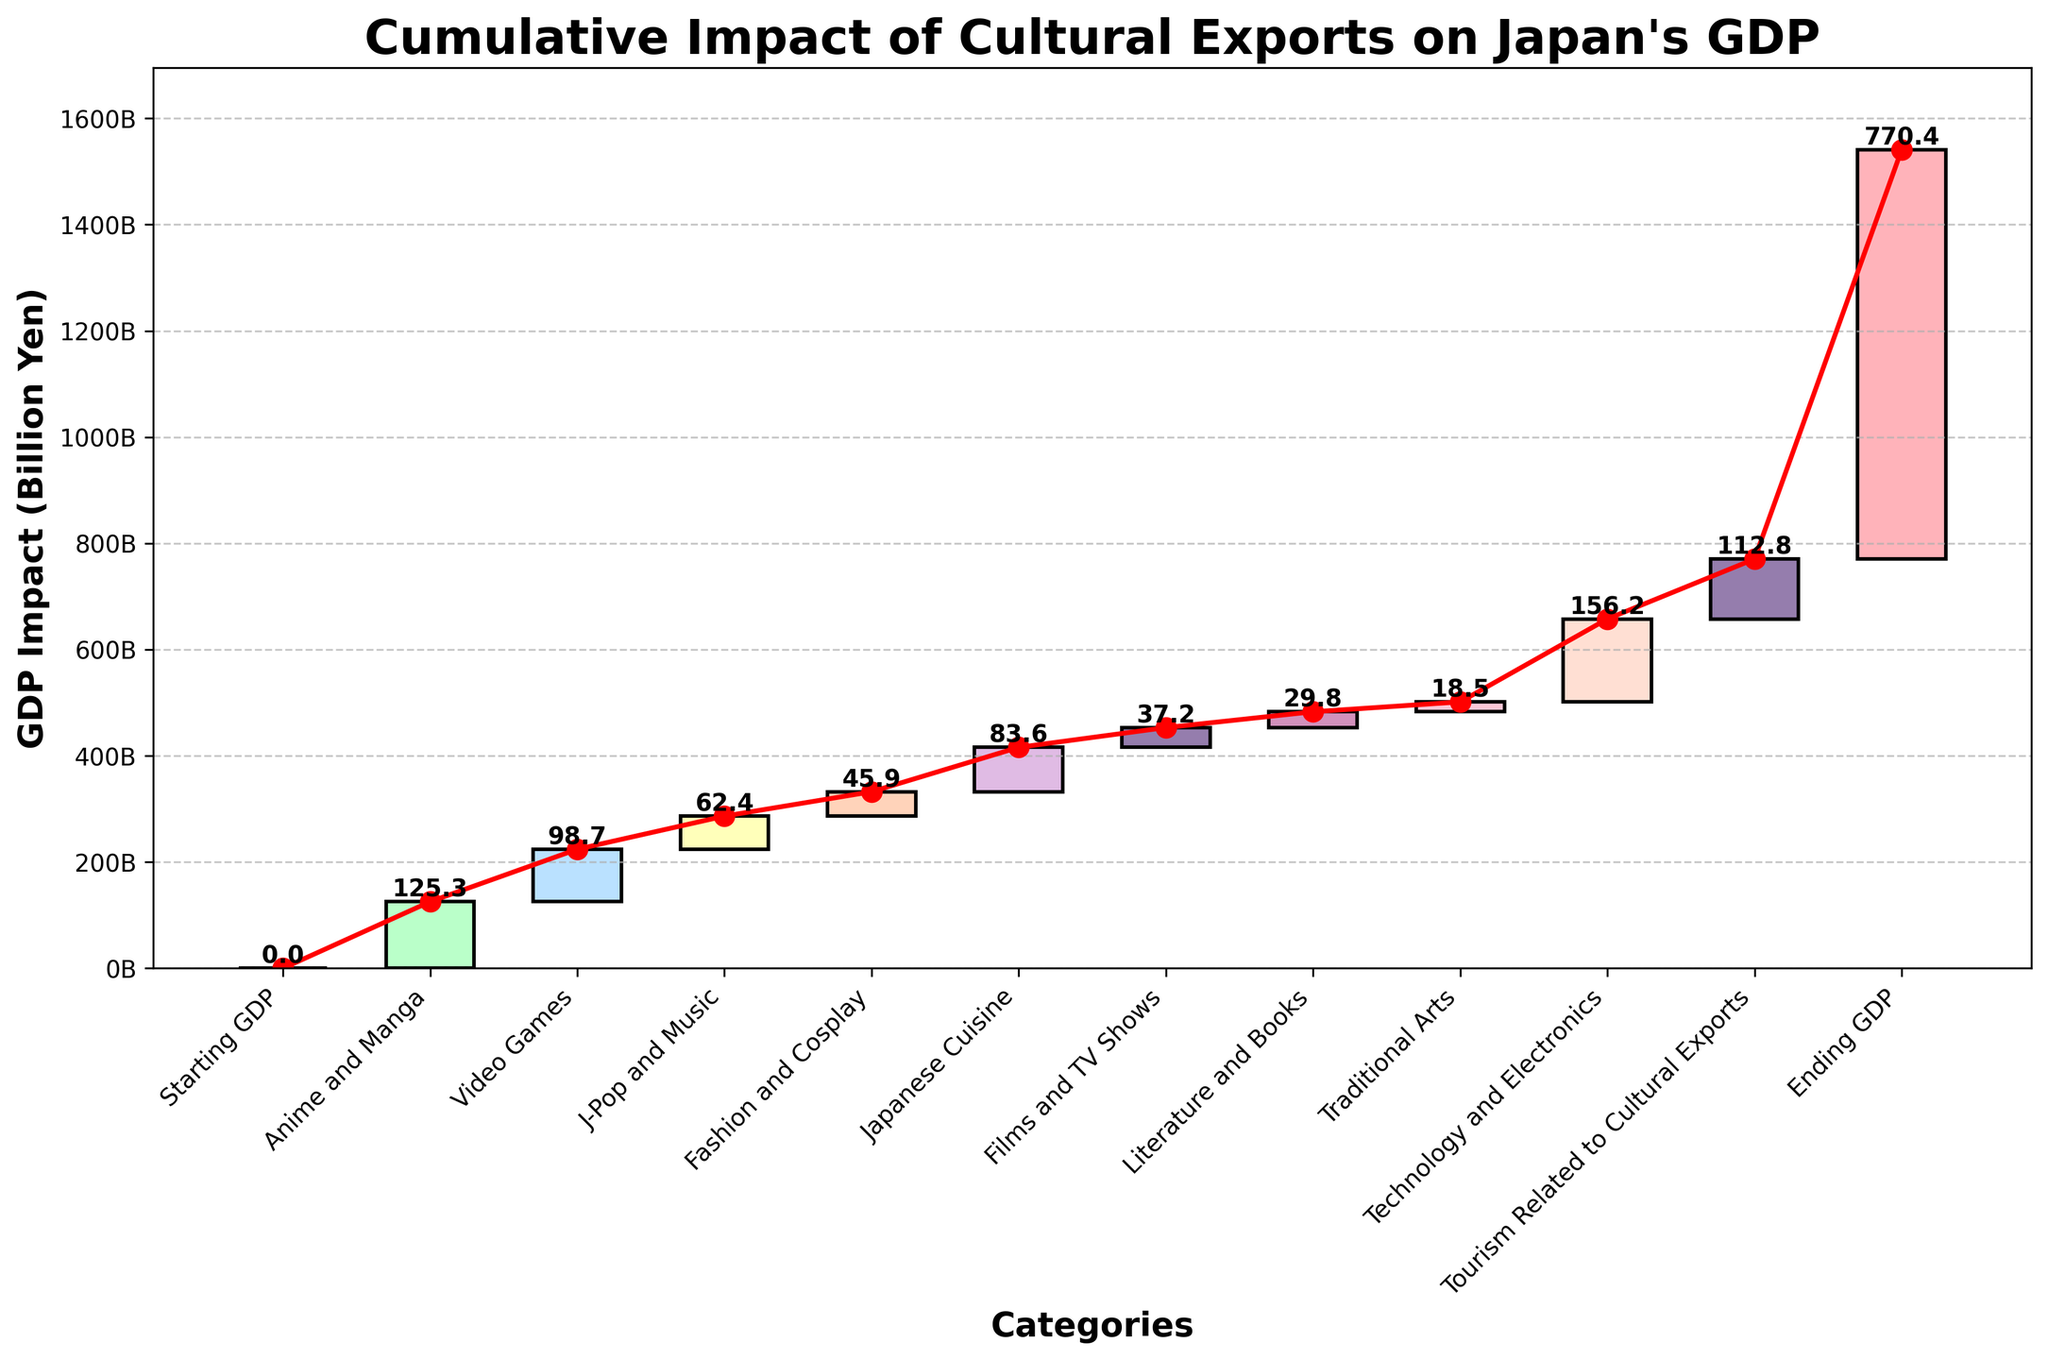What is the title of the plot? The title of the plot is usually positioned at the top of the chart. Reading it directly, it states "Cumulative Impact of Cultural Exports on Japan's GDP."
Answer: Cumulative Impact of Cultural Exports on Japan's GDP What is the GDP impact of Japanese Cuisine? Locate the bar labeled "Japanese Cuisine" on the x-axis. The value labeled at the top of this bar is 83.6 billion yen.
Answer: 83.6 billion yen Which category has the highest impact on Japan's GDP? Compare the heights of all bars to determine which one reaches the highest value. The "Technology and Electronics" category has the highest impact with 156.2 billion yen.
Answer: Technology and Electronics How much cumulative GDP impact is observed by the time J-Pop and Music is included? Sum the values starting from "Anime and Manga" to "J-Pop and Music." The cumulative value is 125.3 + 98.7 + 62.4 = 286.4 billion yen.
Answer: 286.4 billion yen What is the average GDP impact of all categories excluding "Starting GDP" and "Ending GDP"? Sum all category values excluding "Starting GDP" and "Ending GDP" (125.3 + 98.7 + 62.4 + 45.9 + 83.6 + 37.2 + 29.8 + 18.5 + 156.2 + 112.8), then divide by the number of categories, which is 10. The calculation is (770.4) / 10 = 77.04 billion yen.
Answer: 77.04 billion yen By how much does the impact of "Anime and Manga" exceed "Literature and Books"? Subtract the GDP impact of "Literature and Books" from "Anime and Manga" (125.3 - 29.8 = 95.5 billion yen).
Answer: 95.5 billion yen Which category contributes least to the GDP impact? Identify the bar with the lowest value. "Traditional Arts" has the smallest GDP impact, being 18.5 billion yen.
Answer: Traditional Arts How much greater is the impact of "Video Games" compared to "Fashion and Cosplay"? Subtract the GDP impact of "Fashion and Cosplay" from "Video Games" (98.7 - 45.9 = 52.8 billion yen).
Answer: 52.8 billion yen What is the cumulative GDP impact after including "Technology and Electronics" but before "Tourism Related to Cultural Exports"? Add the values: 125.3 + 98.7 + 62.4 + 45.9 + 83.6 + 37.2 + 29.8 + 18.5 + 156.2 = 657.6 billion yen.
Answer: 657.6 billion yen What is the total GDP impact gain observed from all cultural exports combined? The "Ending GDP" value minus the "Starting GDP" value provides the total GDP impact gain (770.4 billion yen). Since "Starting GDP" is zero, the total gain is simply the "Ending GDP" value.
Answer: 770.4 billion yen 